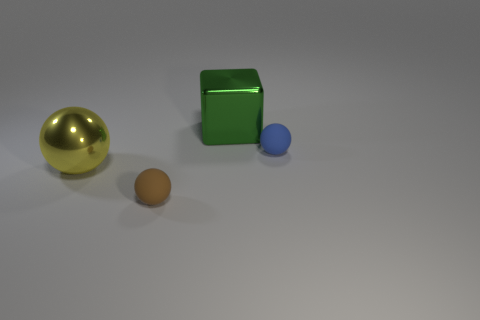There is a tiny object that is behind the yellow ball that is in front of the metal thing behind the yellow metallic thing; what color is it? The small object you are referring to appears to be a blue sphere. It's positioned behind the yellow ball and in front of the reflective green cube, which in turn is situated before a larger metallic gray structure. The contrast between the blue sphere and the other objects in the scene provides a subtle hint of depth to the composition. 